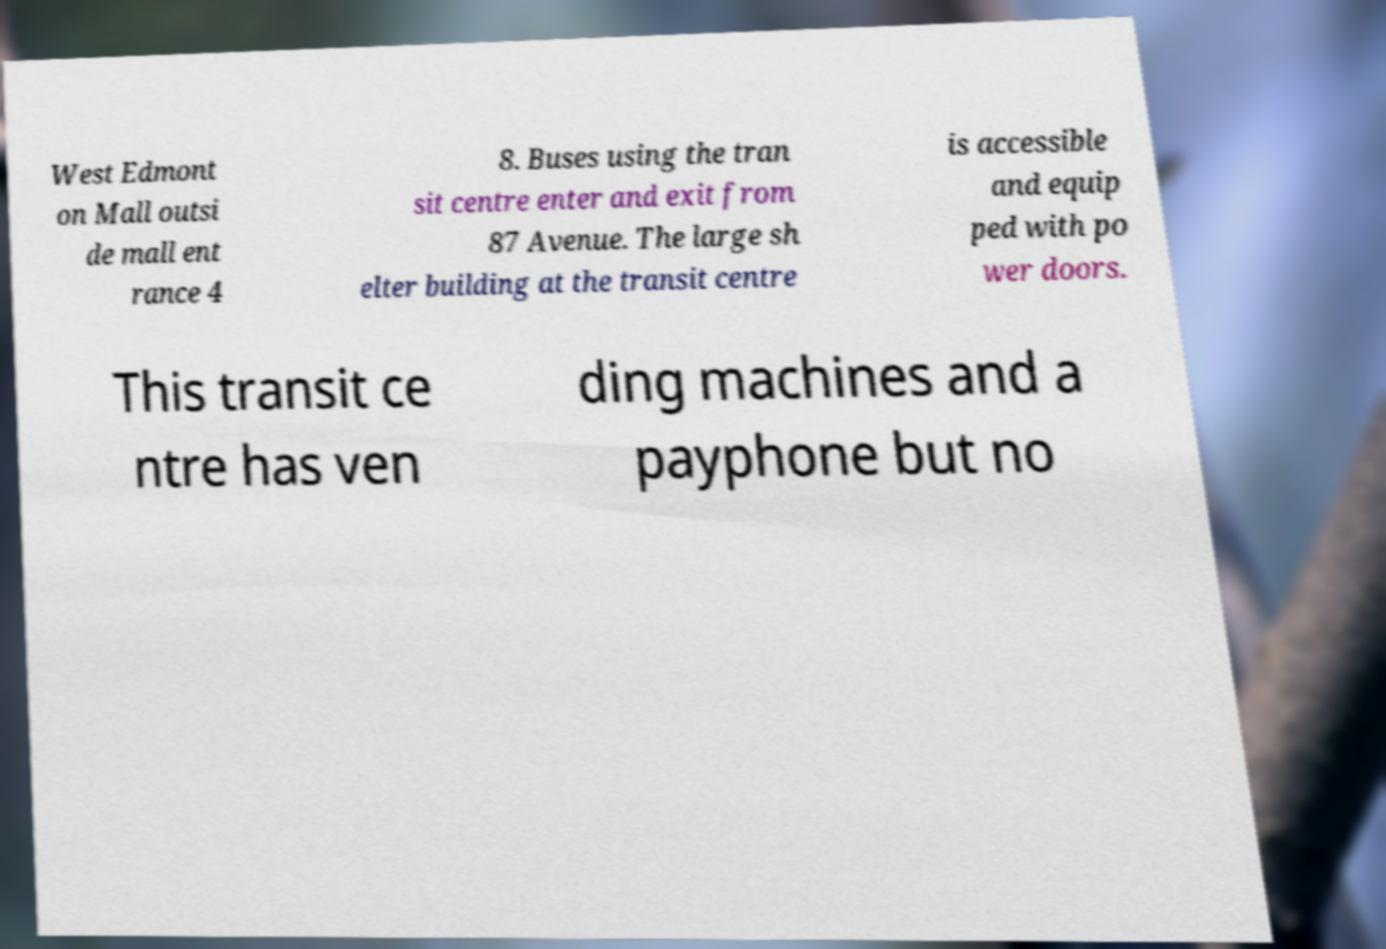Can you read and provide the text displayed in the image?This photo seems to have some interesting text. Can you extract and type it out for me? West Edmont on Mall outsi de mall ent rance 4 8. Buses using the tran sit centre enter and exit from 87 Avenue. The large sh elter building at the transit centre is accessible and equip ped with po wer doors. This transit ce ntre has ven ding machines and a payphone but no 